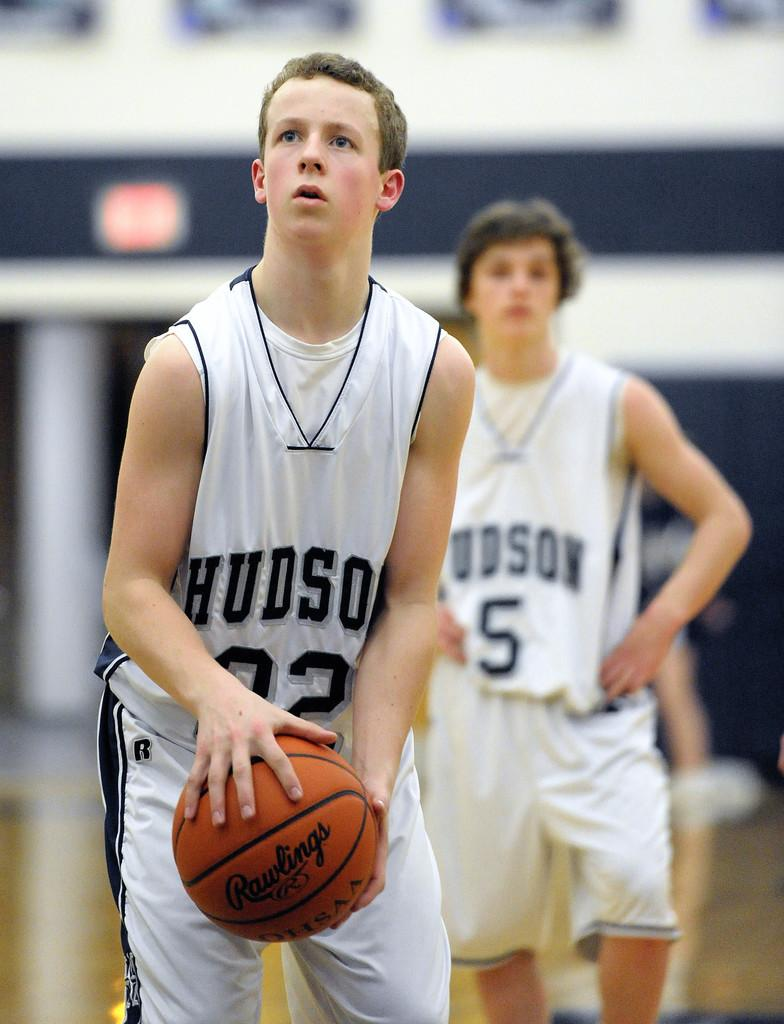<image>
Describe the image concisely. A young man in a Hudson jersey and a number 02 is holding a basketball 